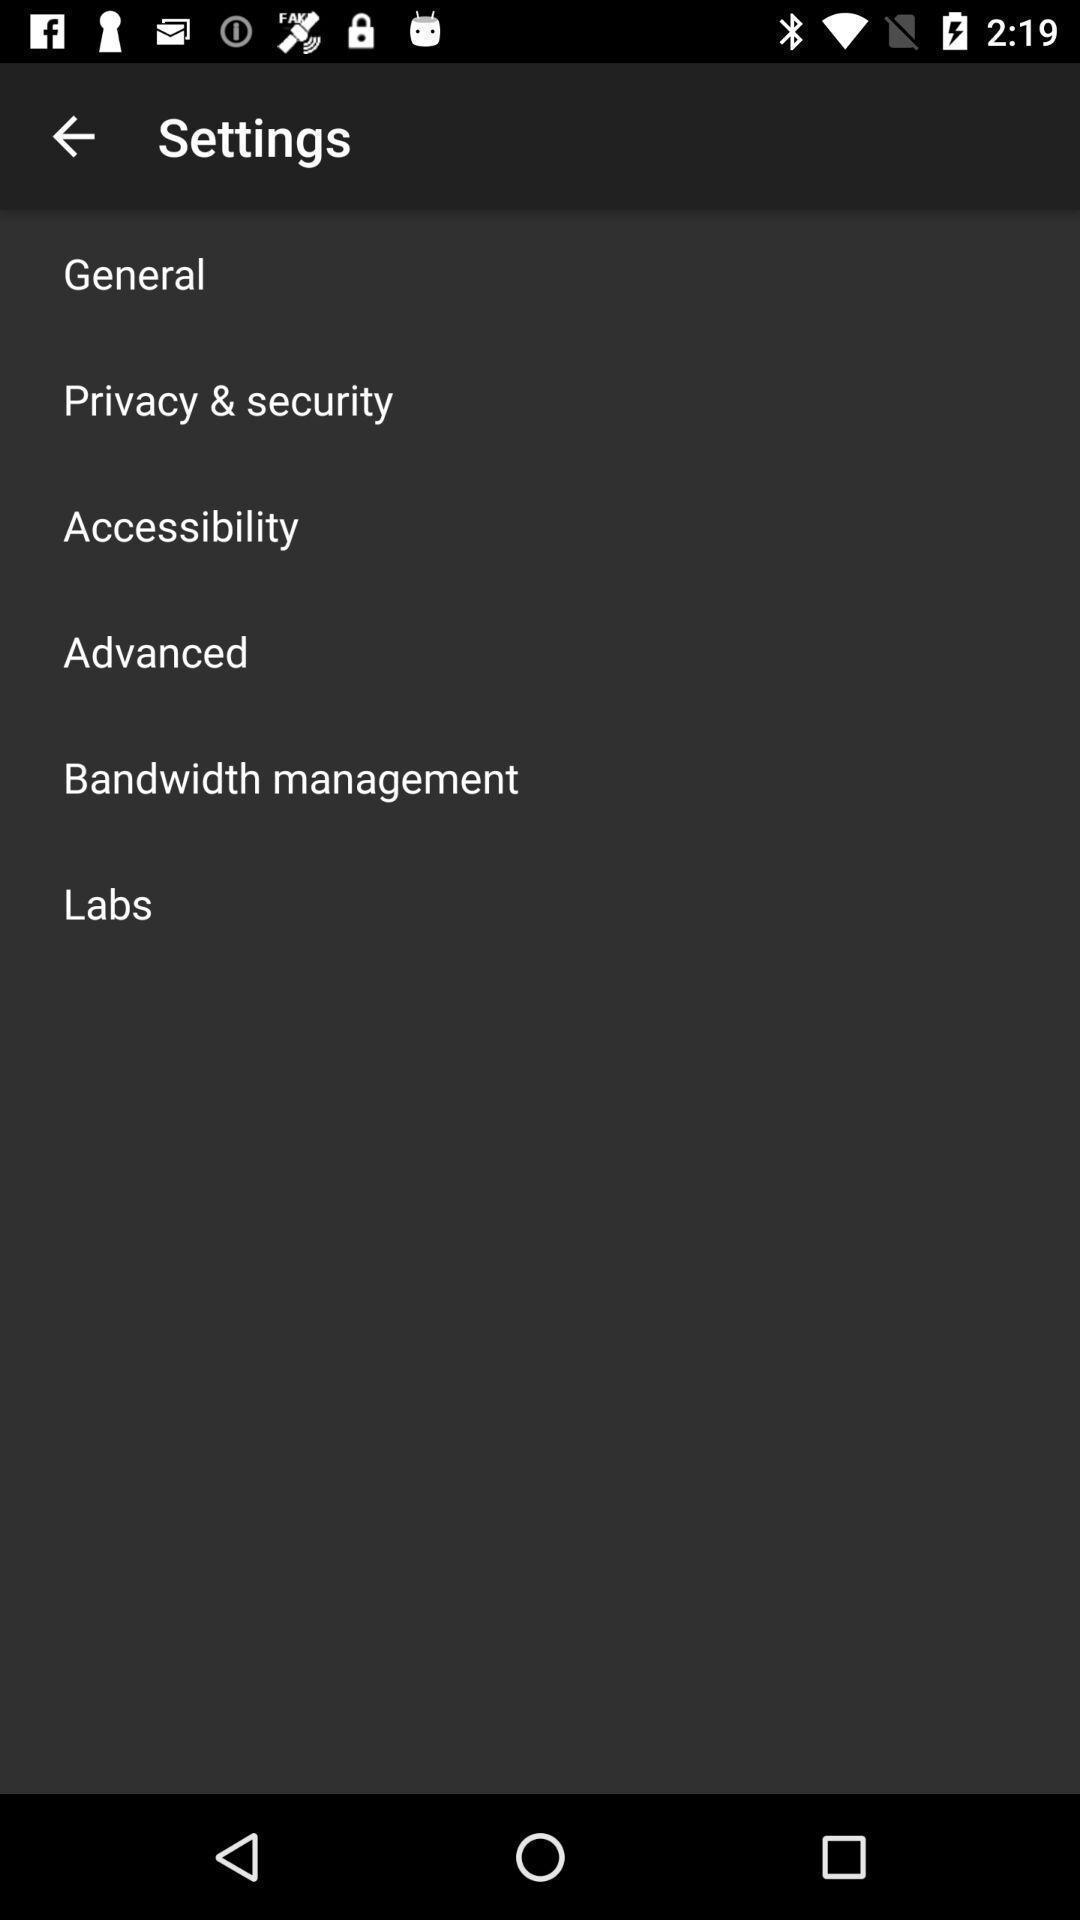Explain what's happening in this screen capture. Screen shows settings. 